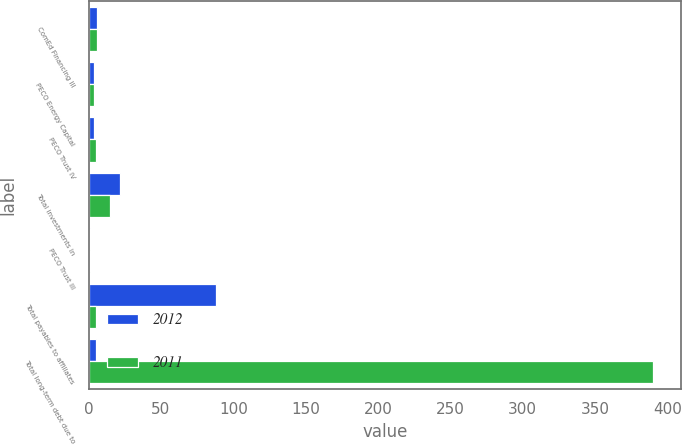Convert chart. <chart><loc_0><loc_0><loc_500><loc_500><stacked_bar_chart><ecel><fcel>ComEd Financing III<fcel>PECO Energy Capital<fcel>PECO Trust IV<fcel>Total investments in<fcel>PECO Trust III<fcel>Total payables to affiliates<fcel>Total long-term debt due to<nl><fcel>2012<fcel>6<fcel>4<fcel>4<fcel>22<fcel>1<fcel>88<fcel>5<nl><fcel>2011<fcel>6<fcel>4<fcel>5<fcel>15<fcel>1<fcel>5<fcel>390<nl></chart> 